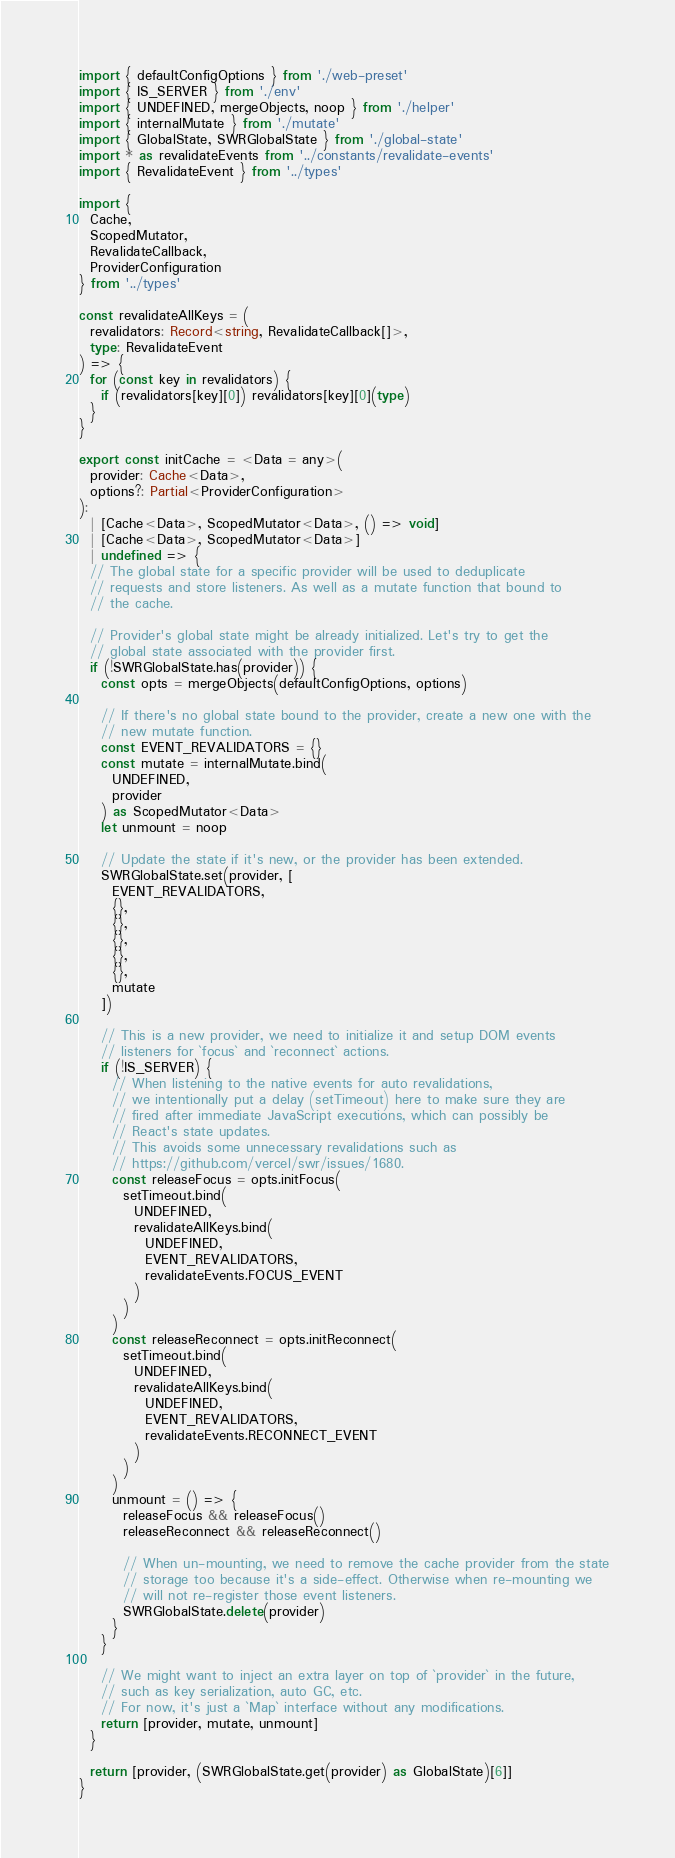Convert code to text. <code><loc_0><loc_0><loc_500><loc_500><_TypeScript_>import { defaultConfigOptions } from './web-preset'
import { IS_SERVER } from './env'
import { UNDEFINED, mergeObjects, noop } from './helper'
import { internalMutate } from './mutate'
import { GlobalState, SWRGlobalState } from './global-state'
import * as revalidateEvents from '../constants/revalidate-events'
import { RevalidateEvent } from '../types'

import {
  Cache,
  ScopedMutator,
  RevalidateCallback,
  ProviderConfiguration
} from '../types'

const revalidateAllKeys = (
  revalidators: Record<string, RevalidateCallback[]>,
  type: RevalidateEvent
) => {
  for (const key in revalidators) {
    if (revalidators[key][0]) revalidators[key][0](type)
  }
}

export const initCache = <Data = any>(
  provider: Cache<Data>,
  options?: Partial<ProviderConfiguration>
):
  | [Cache<Data>, ScopedMutator<Data>, () => void]
  | [Cache<Data>, ScopedMutator<Data>]
  | undefined => {
  // The global state for a specific provider will be used to deduplicate
  // requests and store listeners. As well as a mutate function that bound to
  // the cache.

  // Provider's global state might be already initialized. Let's try to get the
  // global state associated with the provider first.
  if (!SWRGlobalState.has(provider)) {
    const opts = mergeObjects(defaultConfigOptions, options)

    // If there's no global state bound to the provider, create a new one with the
    // new mutate function.
    const EVENT_REVALIDATORS = {}
    const mutate = internalMutate.bind(
      UNDEFINED,
      provider
    ) as ScopedMutator<Data>
    let unmount = noop

    // Update the state if it's new, or the provider has been extended.
    SWRGlobalState.set(provider, [
      EVENT_REVALIDATORS,
      {},
      {},
      {},
      {},
      {},
      mutate
    ])

    // This is a new provider, we need to initialize it and setup DOM events
    // listeners for `focus` and `reconnect` actions.
    if (!IS_SERVER) {
      // When listening to the native events for auto revalidations,
      // we intentionally put a delay (setTimeout) here to make sure they are
      // fired after immediate JavaScript executions, which can possibly be
      // React's state updates.
      // This avoids some unnecessary revalidations such as
      // https://github.com/vercel/swr/issues/1680.
      const releaseFocus = opts.initFocus(
        setTimeout.bind(
          UNDEFINED,
          revalidateAllKeys.bind(
            UNDEFINED,
            EVENT_REVALIDATORS,
            revalidateEvents.FOCUS_EVENT
          )
        )
      )
      const releaseReconnect = opts.initReconnect(
        setTimeout.bind(
          UNDEFINED,
          revalidateAllKeys.bind(
            UNDEFINED,
            EVENT_REVALIDATORS,
            revalidateEvents.RECONNECT_EVENT
          )
        )
      )
      unmount = () => {
        releaseFocus && releaseFocus()
        releaseReconnect && releaseReconnect()

        // When un-mounting, we need to remove the cache provider from the state
        // storage too because it's a side-effect. Otherwise when re-mounting we
        // will not re-register those event listeners.
        SWRGlobalState.delete(provider)
      }
    }

    // We might want to inject an extra layer on top of `provider` in the future,
    // such as key serialization, auto GC, etc.
    // For now, it's just a `Map` interface without any modifications.
    return [provider, mutate, unmount]
  }

  return [provider, (SWRGlobalState.get(provider) as GlobalState)[6]]
}
</code> 